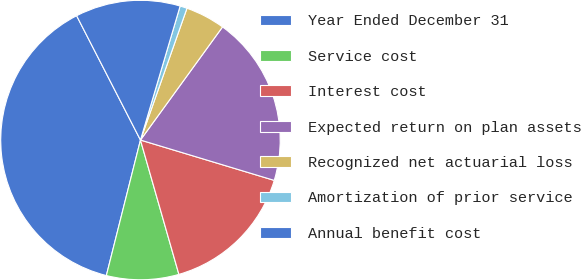Convert chart. <chart><loc_0><loc_0><loc_500><loc_500><pie_chart><fcel>Year Ended December 31<fcel>Service cost<fcel>Interest cost<fcel>Expected return on plan assets<fcel>Recognized net actuarial loss<fcel>Amortization of prior service<fcel>Annual benefit cost<nl><fcel>38.52%<fcel>8.36%<fcel>15.9%<fcel>19.67%<fcel>4.59%<fcel>0.82%<fcel>12.13%<nl></chart> 